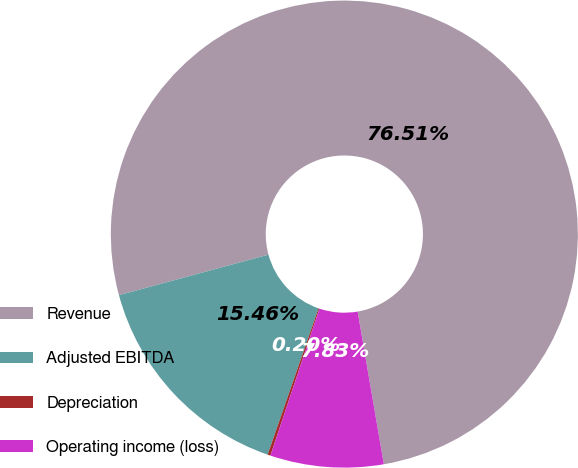Convert chart to OTSL. <chart><loc_0><loc_0><loc_500><loc_500><pie_chart><fcel>Revenue<fcel>Adjusted EBITDA<fcel>Depreciation<fcel>Operating income (loss)<nl><fcel>76.5%<fcel>15.46%<fcel>0.2%<fcel>7.83%<nl></chart> 